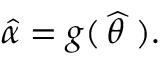<formula> <loc_0><loc_0><loc_500><loc_500>{ \widehat { \alpha } } = g ( \, { \widehat { \theta \, } } \, ) .</formula> 